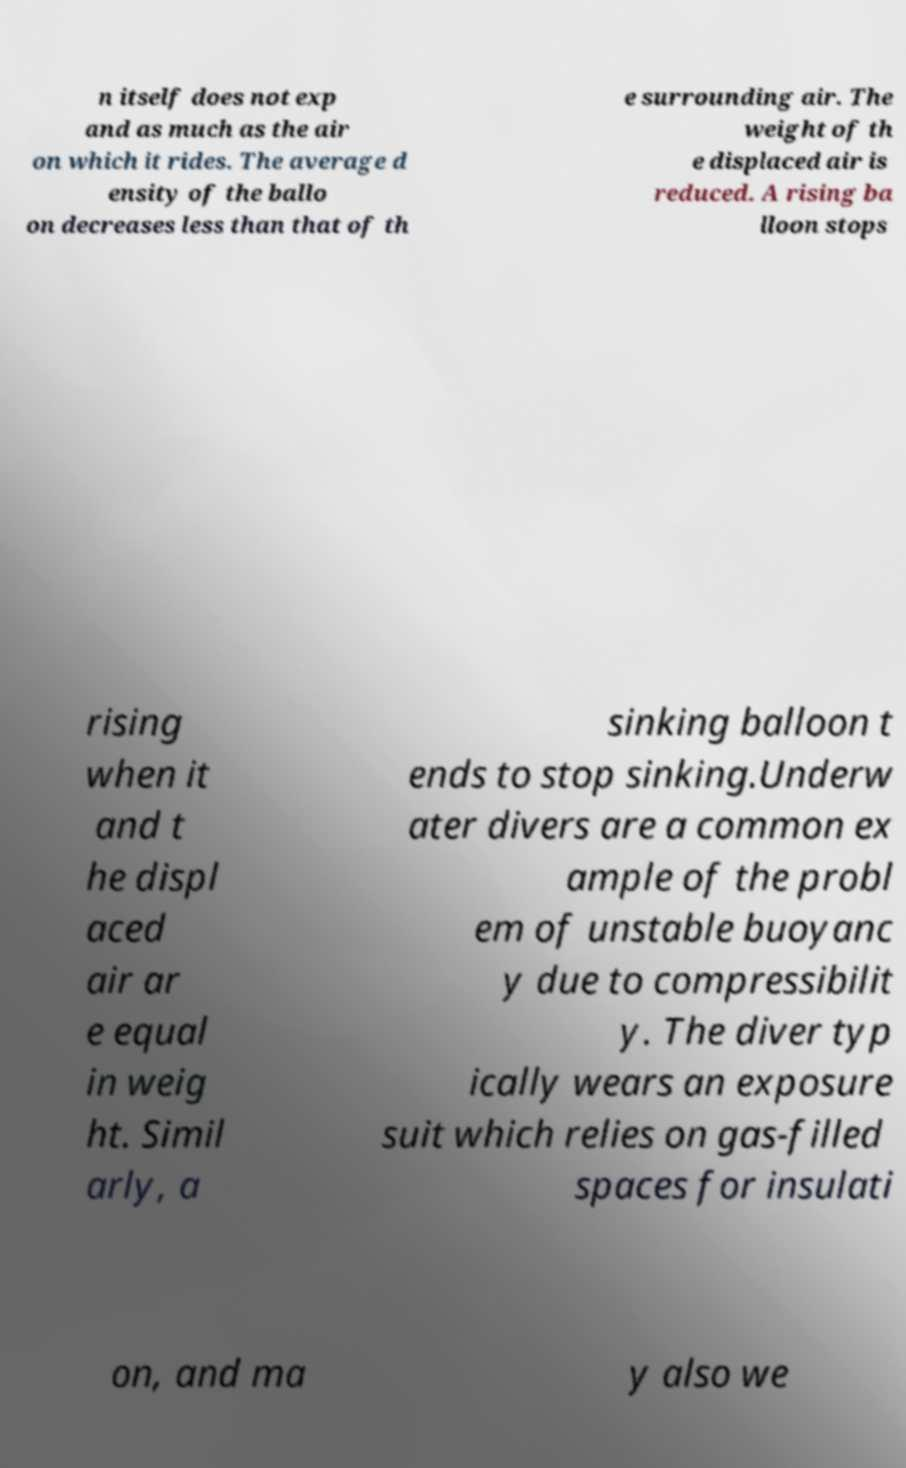Please read and relay the text visible in this image. What does it say? n itself does not exp and as much as the air on which it rides. The average d ensity of the ballo on decreases less than that of th e surrounding air. The weight of th e displaced air is reduced. A rising ba lloon stops rising when it and t he displ aced air ar e equal in weig ht. Simil arly, a sinking balloon t ends to stop sinking.Underw ater divers are a common ex ample of the probl em of unstable buoyanc y due to compressibilit y. The diver typ ically wears an exposure suit which relies on gas-filled spaces for insulati on, and ma y also we 